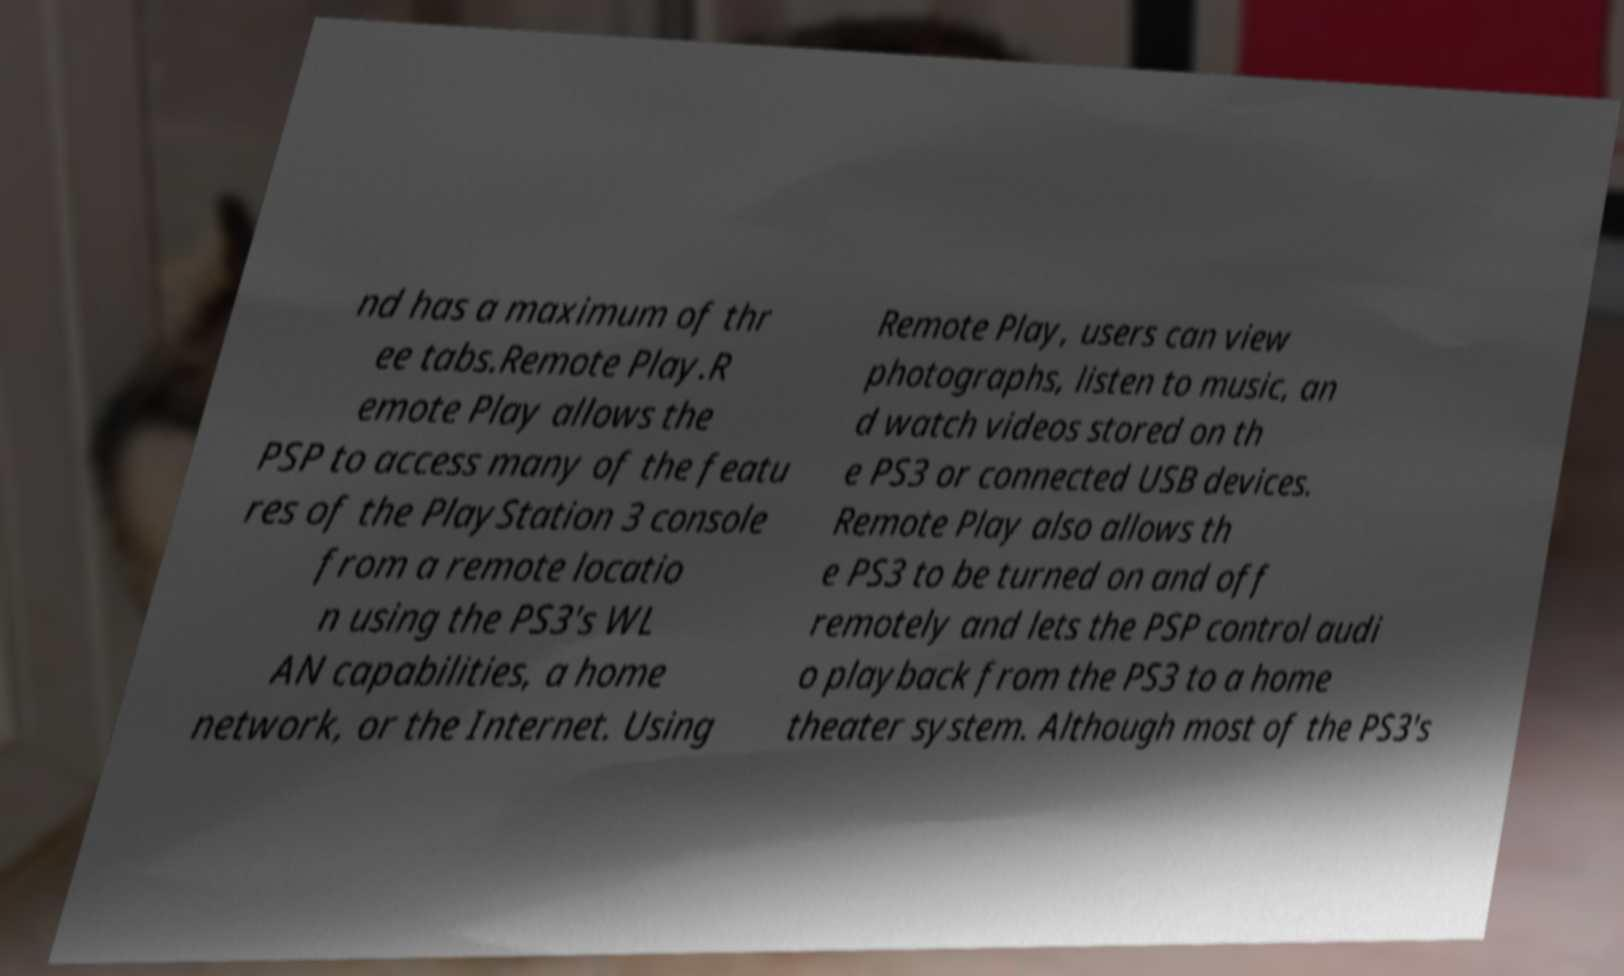Could you extract and type out the text from this image? nd has a maximum of thr ee tabs.Remote Play.R emote Play allows the PSP to access many of the featu res of the PlayStation 3 console from a remote locatio n using the PS3's WL AN capabilities, a home network, or the Internet. Using Remote Play, users can view photographs, listen to music, an d watch videos stored on th e PS3 or connected USB devices. Remote Play also allows th e PS3 to be turned on and off remotely and lets the PSP control audi o playback from the PS3 to a home theater system. Although most of the PS3's 